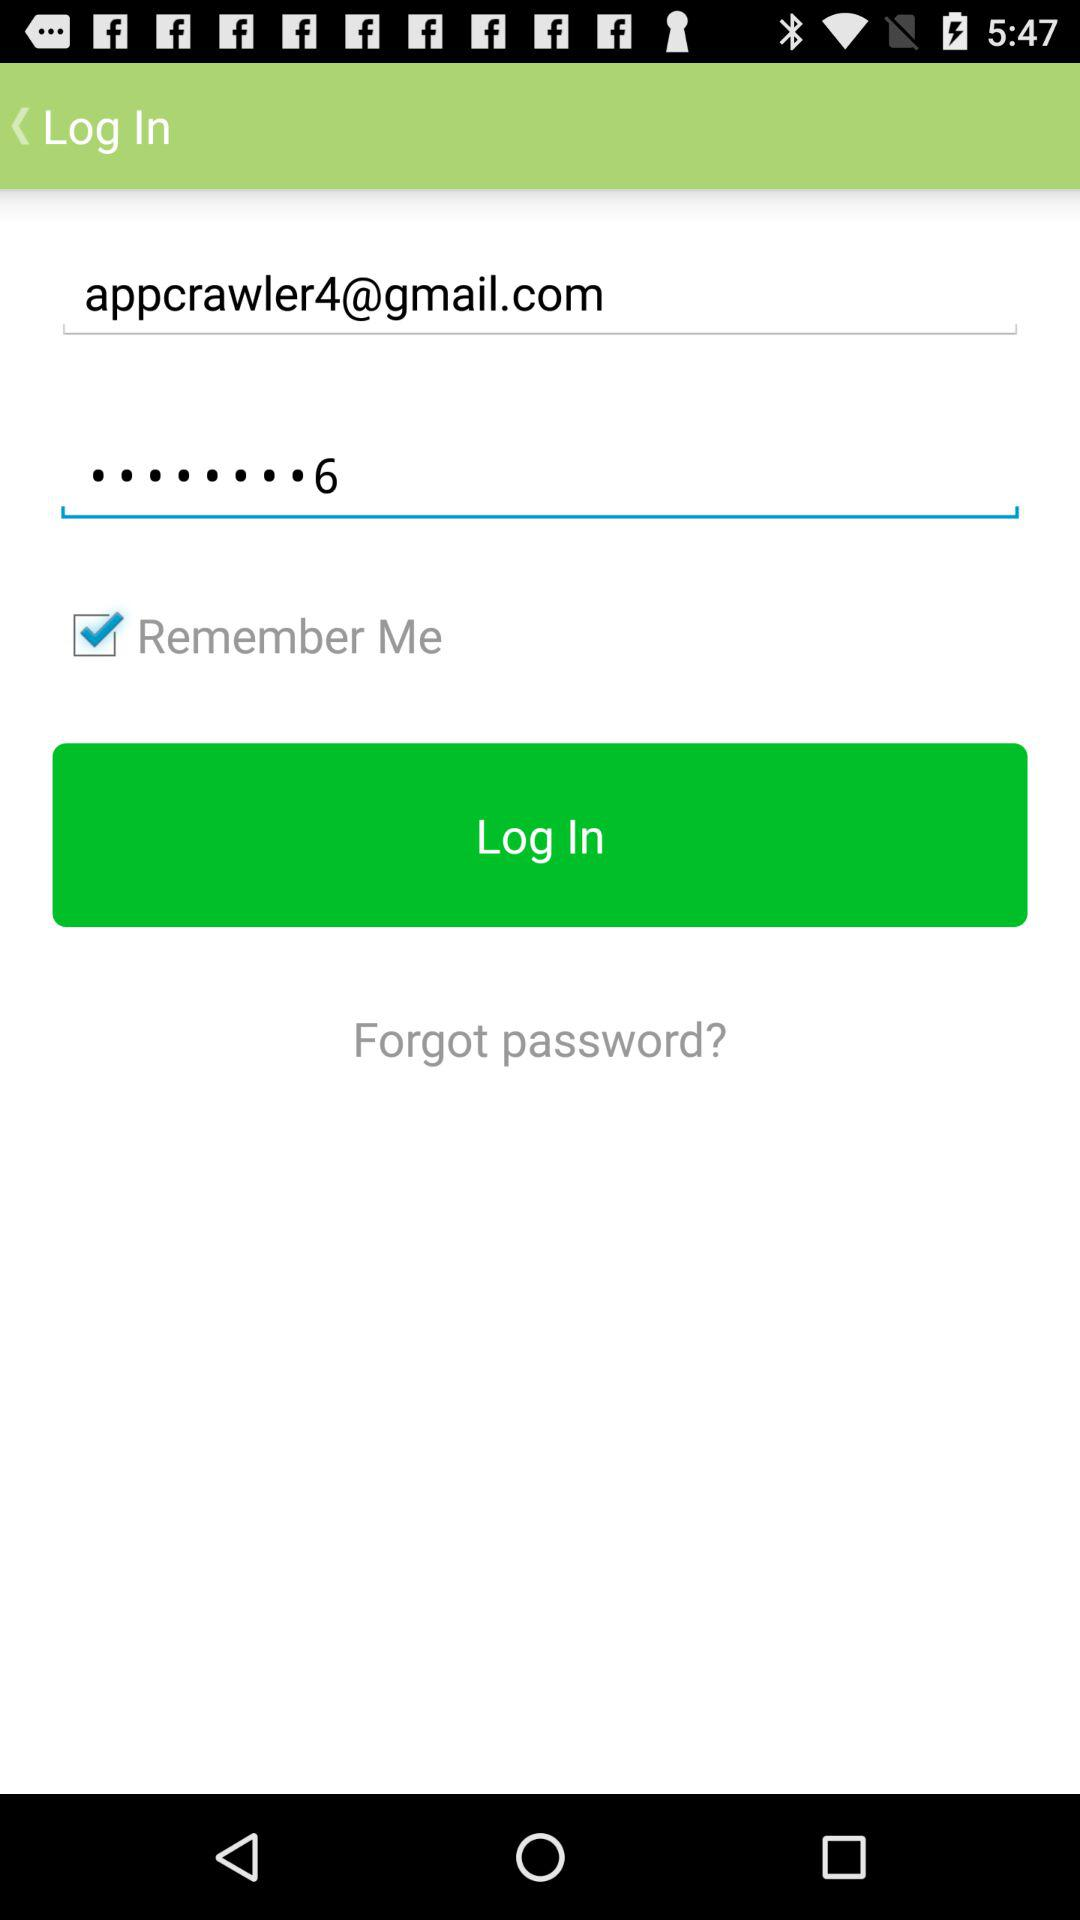What is the e-mail address? The e-mail address is appcrawler4@gmail.com. 